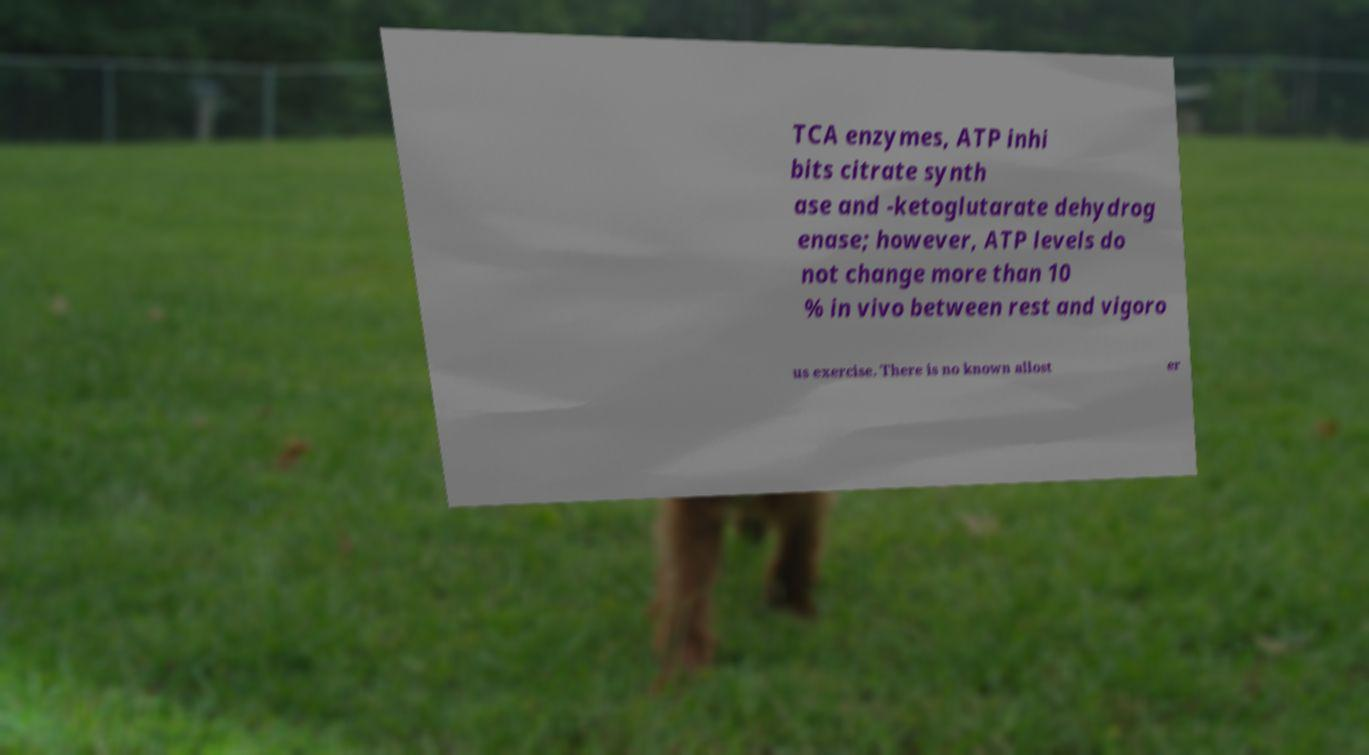What messages or text are displayed in this image? I need them in a readable, typed format. TCA enzymes, ATP inhi bits citrate synth ase and -ketoglutarate dehydrog enase; however, ATP levels do not change more than 10 % in vivo between rest and vigoro us exercise. There is no known allost er 